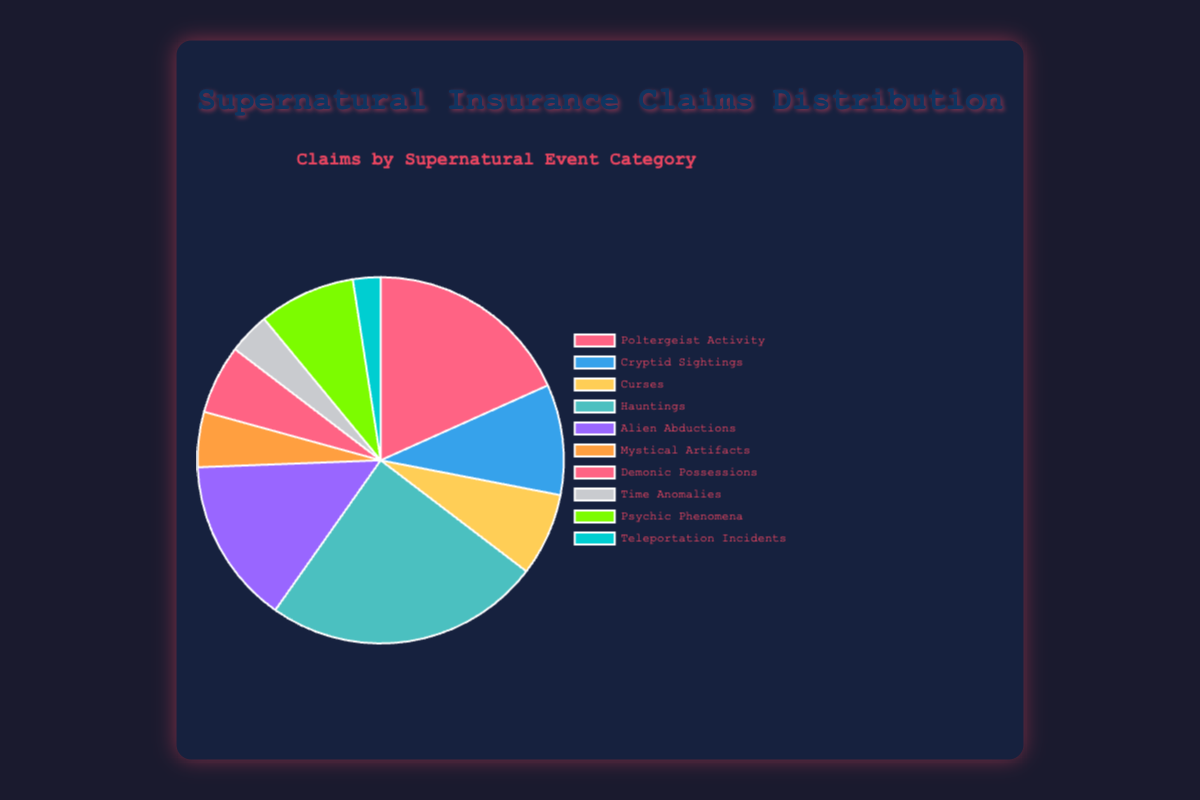What's the most common supernatural event category based on claims? The figure shows that the segment representing hauntings is the largest.
Answer: Hauntings Which supernatural event category has the least number of claims? By observing the segments, the smallest one corresponds to teleportation incidents.
Answer: Teleportation Incidents How many claims are there in total? Sum all the claims from each category: 150 (Poltergeist Activity) + 80 (Cryptid Sightings) + 60 (Curses) + 200 (Hauntings) + 120 (Alien Abductions) + 40 (Mystical Artifacts) + 50 (Demonic Possessions) + 30 (Time Anomalies) + 70 (Psychic Phenomena) + 20 (Teleportation Incidents) = 820.
Answer: 820 What is the percentage of claims for Alien Abductions? Alien Abductions have 120 claims; total claims are 820. So, (120 / 820) * 100 ≈ 14.63%.
Answer: 14.63% Are claims for Hauntings more than double those for Poltergeist Activity? Hauntings have 200 claims and Poltergeist Activity has 150 claims. Double of 150 is 300, so 200 is not more than double.
Answer: No What's the difference in the number of claims between Cryptid Sightings and Psychic Phenomena? Cryptid Sightings have 80 claims, while Psychic Phenomena have 70 claims. 80 - 70 = 10.
Answer: 10 How many claims are recorded for categories with fewer than 50 claims each? Categories with fewer than 50 claims are Mystical Artifacts (40 claims), Demonic Possessions (50 claims), Time Anomalies (30 claims), and Teleportation Incidents (20 claims). Total = 40 + 50 + 30 + 20 = 140.
Answer: 140 Which category accounts for the smallest fraction in the chart without referring to the exact numbers? Observing the chart visually, the smallest segment in the pie chart corresponds to Teleportation Incidents.
Answer: Teleportation Incidents What percentage of total claims do Poltergeist Activity and Hauntings together constitute? Poltergeist Activity has 150 claims and Hauntings have 200 claims. Combined: 150 + 200 = 350. (350 / 820) * 100 ≈ 42.68%.
Answer: 42.68% 